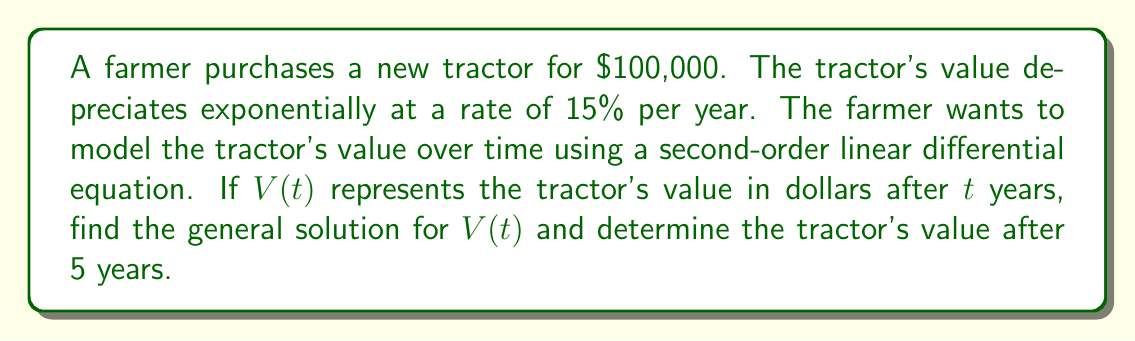Show me your answer to this math problem. To model the tractor's value using exponential decay, we start with the first-order differential equation:

$$\frac{dV}{dt} = -kV$$

Where $k$ is the decay constant. Given the annual depreciation rate of 15%, we have $k = 0.15$.

To convert this into a second-order linear differential equation, we differentiate both sides:

$$\frac{d^2V}{dt^2} = -k\frac{dV}{dt}$$

Substituting $\frac{dV}{dt} = -kV$ from the original equation:

$$\frac{d^2V}{dt^2} = k^2V$$

Now we have the second-order linear differential equation:

$$\frac{d^2V}{dt^2} - k^2V = 0$$

The characteristic equation for this differential equation is:

$$r^2 - k^2 = 0$$

Solving for $r$:

$$r = \pm k = \pm 0.15$$

The general solution for $V(t)$ is:

$$V(t) = C_1e^{kt} + C_2e^{-kt}$$

Where $C_1$ and $C_2$ are constants determined by initial conditions.

Given the initial value $V(0) = 100,000$ and the fact that the value decreases over time, we can deduce that $C_1 = 0$ and $C_2 = 100,000$.

Therefore, the specific solution for $V(t)$ is:

$$V(t) = 100,000e^{-0.15t}$$

To find the tractor's value after 5 years, we substitute $t = 5$:

$$V(5) = 100,000e^{-0.15(5)} = 100,000e^{-0.75} \approx 47,236.66$$
Answer: The general solution for $V(t)$ is $V(t) = C_1e^{0.15t} + C_2e^{-0.15t}$, and the tractor's value after 5 years is approximately $47,236.66. 